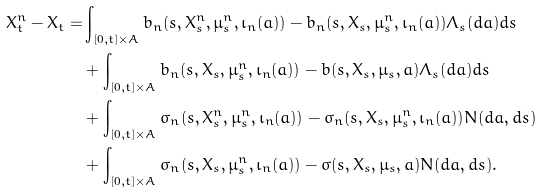Convert formula to latex. <formula><loc_0><loc_0><loc_500><loc_500>X ^ { n } _ { t } - X _ { t } = & \int _ { [ 0 , t ] \times A } b _ { n } ( s , X ^ { n } _ { s } , \mu ^ { n } _ { s } , \iota _ { n } ( a ) ) - b _ { n } ( s , X _ { s } , \mu ^ { n } _ { s } , \iota _ { n } ( a ) ) \Lambda _ { s } ( d a ) d s \\ & + \int _ { [ 0 , t ] \times A } b _ { n } ( s , X _ { s } , \mu ^ { n } _ { s } , \iota _ { n } ( a ) ) - b ( s , X _ { s } , \mu _ { s } , a ) \Lambda _ { s } ( d a ) d s \\ & + \int _ { [ 0 , t ] \times A } \sigma _ { n } ( s , X ^ { n } _ { s } , \mu ^ { n } _ { s } , \iota _ { n } ( a ) ) - \sigma _ { n } ( s , X _ { s } , \mu ^ { n } _ { s } , \iota _ { n } ( a ) ) N ( d a , d s ) \\ & + \int _ { [ 0 , t ] \times A } \sigma _ { n } ( s , X _ { s } , \mu ^ { n } _ { s } , \iota _ { n } ( a ) ) - \sigma ( s , X _ { s } , \mu _ { s } , a ) N ( d a , d s ) .</formula> 